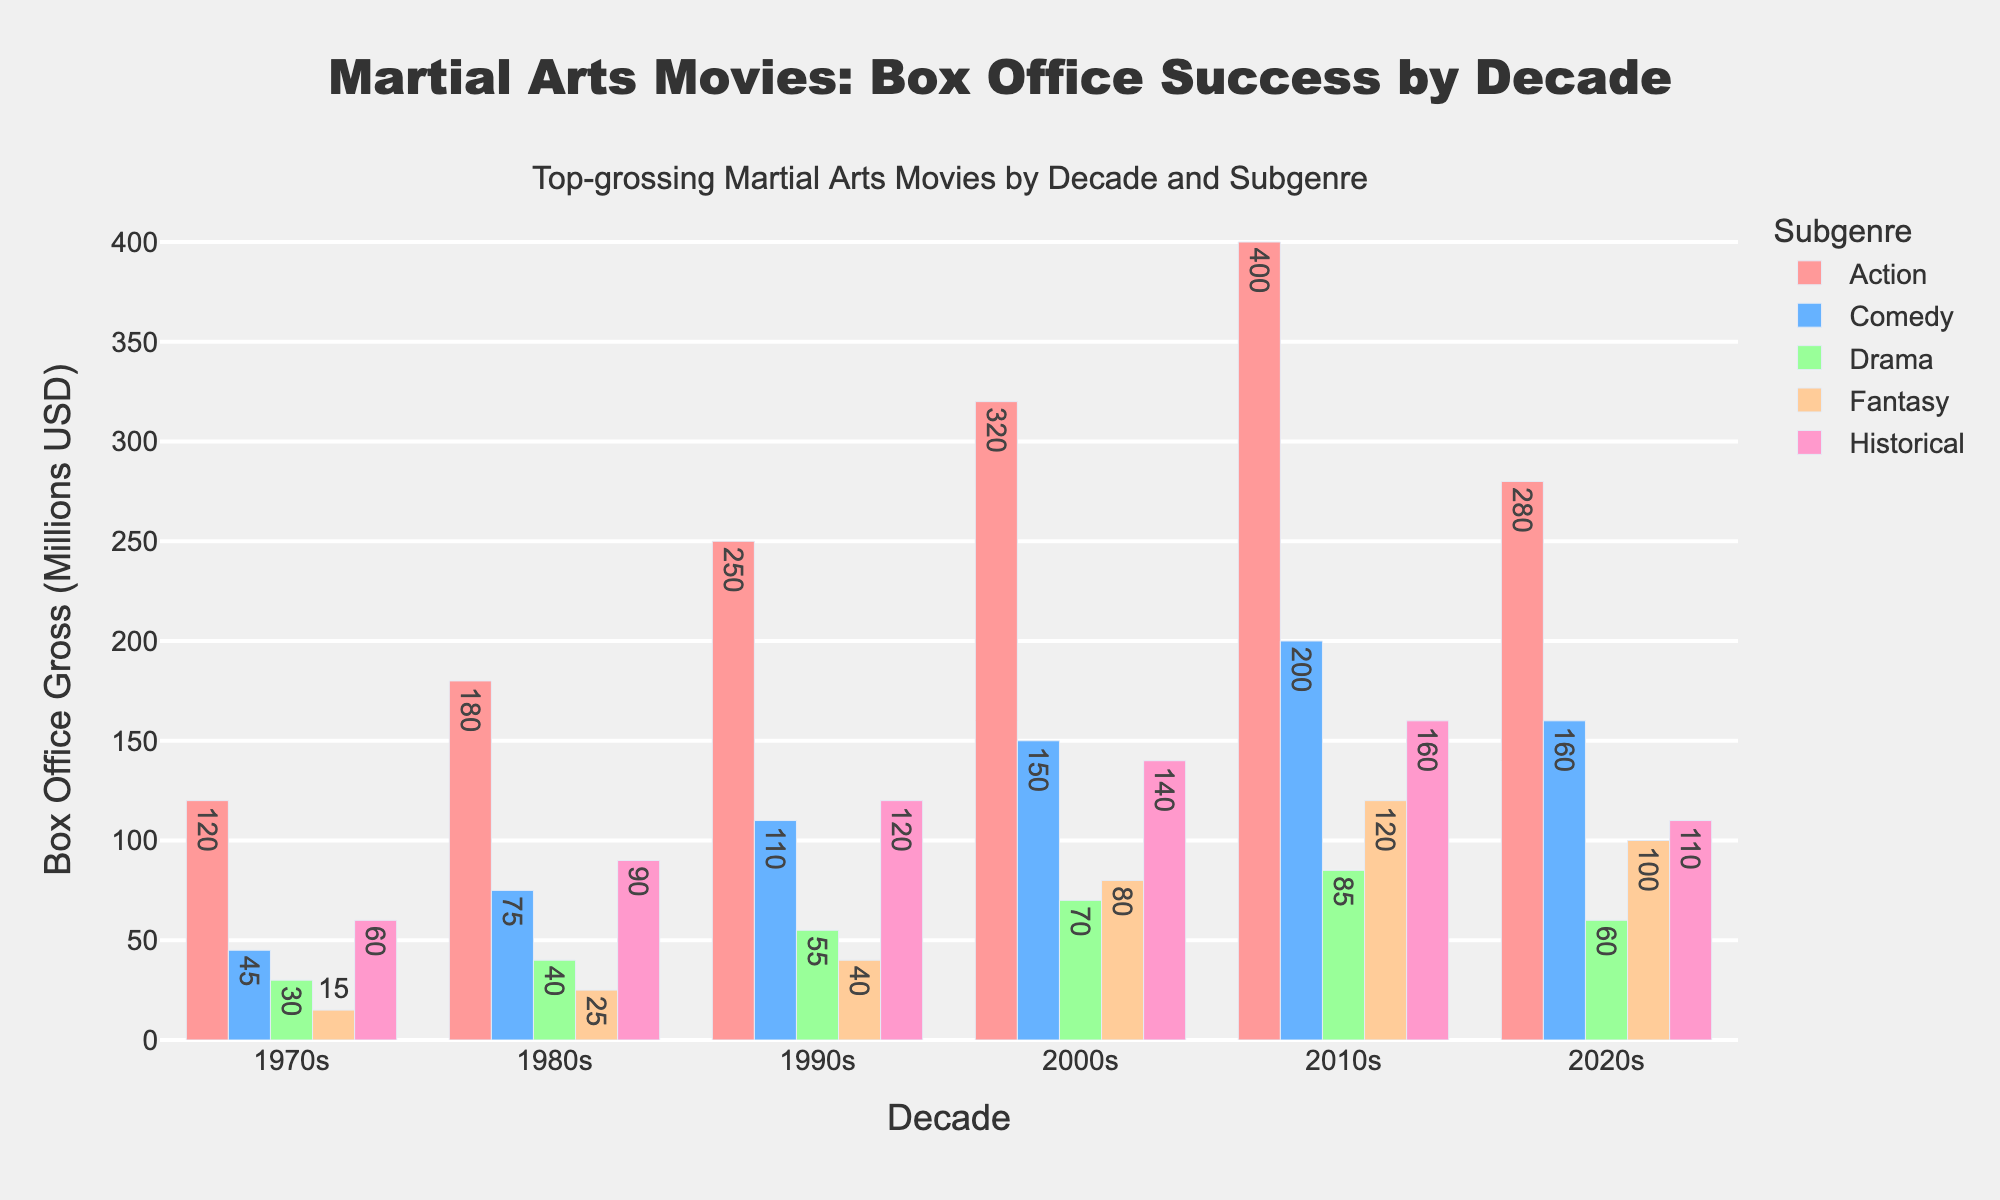What is the total box office gross of the Action subgenre across all decades? Add the box office gross values for the Action subgenre: 120 + 180 + 250 + 320 + 400 + 280 = 1550
Answer: 1550 Which decade had the highest box office gross for Comedy martial arts movies? Compare the values of the Comedy subgenre across all decades: 45, 75, 110, 150, 200, 160. The highest value is 200, which corresponds to the 2010s decade.
Answer: 2010s How does the box office gross of Fantasy martial arts movies in the 2000s compare to that in the 2010s? Look at the values for Fantasy in the 2000s and 2010s: 80 and 120 respectively. 120 is greater than 80, so the Fantasy subgenre grossed more in the 2010s.
Answer: 2010s What is the difference in box office gross between Historical and Drama subgenres in the 1990s? Look at the values for Drama and Historical in the 1990s: 55 and 120 respectively. The difference is 120 - 55 = 65.
Answer: 65 On average, which subgenre had the lowest box office gross per decade? Calculate the average for each subgenre:
1. Action: (120+180+250+320+400+280)/6 = 258.33
2. Comedy: (45+75+110+150+200+160)/6 = 123.33
3. Drama: (30+40+55+70+85+60)/6 = 56.67
4. Fantasy: (15+25+40+80+120+100)/6 = 63.33
5. Historical: (60+90+120+140+160+110)/6 = 113.33
The lowest average is for the Drama subgenre at 56.67.
Answer: Drama What is the combined box office gross for all subgenres in the 2010s? Sum the values for all subgenres in the 2010s: 400 + 200 + 85 + 120 + 160 = 965
Answer: 965 Which subgenre had the most consistent box office gross across all decades? Assess the variance/consistency of each subgenre across all decades:
1. Action: 120, 180, 250, 320, 400, 280
2. Comedy: 45, 75, 110, 150, 200, 160
3. Drama: 30, 40, 55, 70, 85, 60
4. Fantasy: 15, 25, 40, 80, 120, 100
5. Historical: 60, 90, 120, 140, 160, 110
Drama shows relatively consistent increase with least fluctuation.
Answer: Drama What is the ratio of Action to Historical gross in the 1980s? Divide the value for Action by the value for Historical in the 1980s: 180 / 90 = 2
Answer: 2 Which subgenre showed the highest growth in box office gross from the 1970s to the 2010s? Calculate growth for each subgenre and compare:
1. Action: 400 - 120 = 280
2. Comedy: 200 - 45 = 155
3. Drama: 85 - 30 = 55
4. Fantasy: 120 - 15 = 105
5. Historical: 160 - 60 = 100
The highest growth is in the Action subgenre at 280.
Answer: Action 